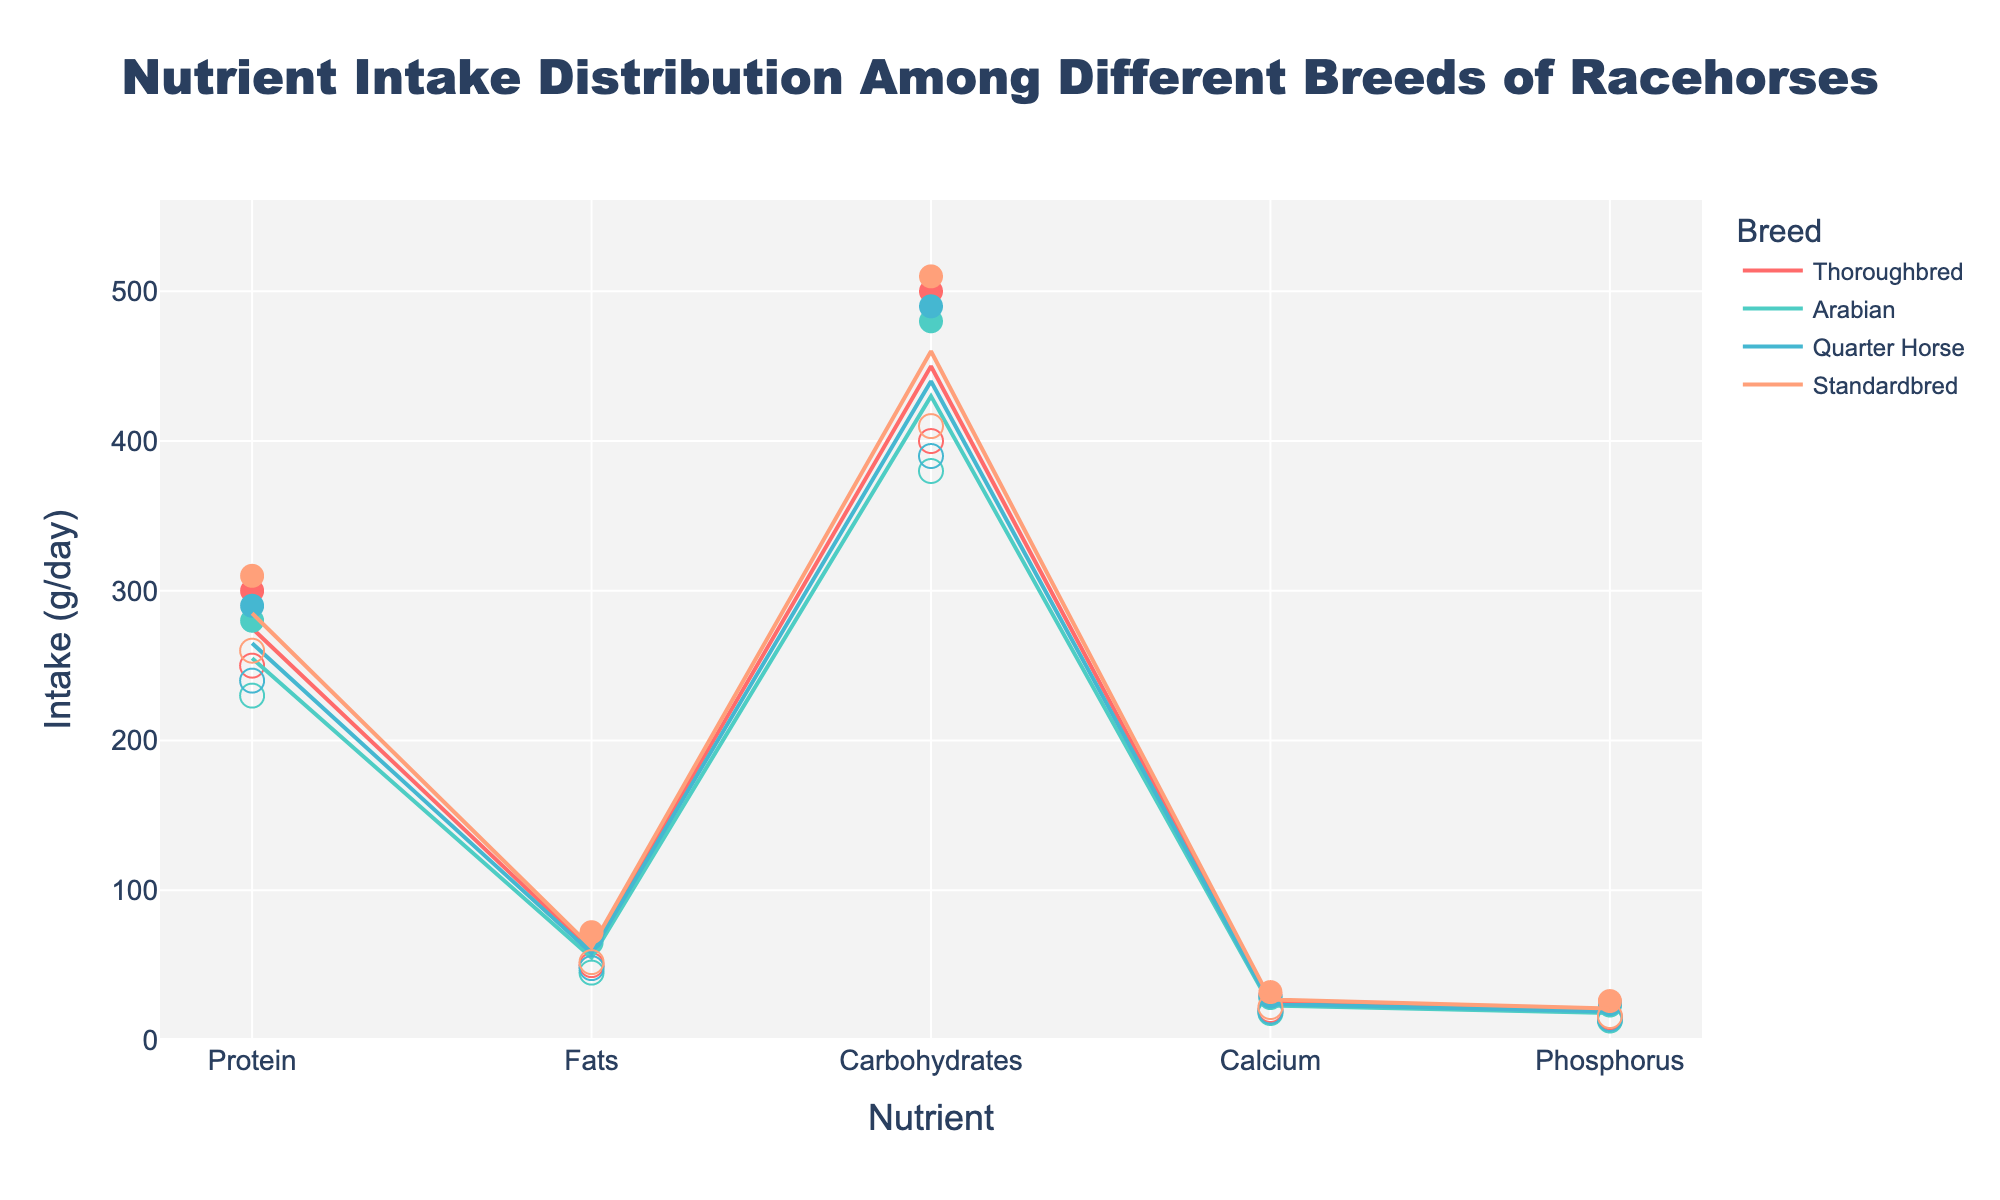Which breed has the highest maximum intake of protein? The highest maximum intake of protein is represented by the dot for protein on the y-axis. Thoroughbreds' max intake of protein is 300g/day, which is the highest.
Answer: Thoroughbred Which nutrient has the smallest range of intake for Thoroughbreds? For each nutrient, find the range (difference between maximum and minimum intake). The smallest difference for Thoroughbreds is in Phosphorus, with a difference of 10g/day.
Answer: Phosphorus Comparing carbohydrates intake, which breed has the lowest minimum intake? Identify the lowest point on the y-axis for carbohydrates among the breeds. Arabian has the lowest minimum intake of carbohydrates at 380g/day.
Answer: Arabian How does the maximum intake of Calcium compare between Thoroughbreds and Standardbreds? Compare the maximum intake values for Calcium between Thoroughbreds (30g/day) and Standardbreds (32g/day). Standardbreds have a slightly higher maximum intake.
Answer: Standardbred has higher What's the average protein intake range for Arabians? Calculate the average by adding the minimum and maximum intake values for protein and dividing by 2 (230g/day + 280g/day) / 2 = 255g/day.
Answer: 255g/day Which breed has the smallest range of intake for fats? Determine the difference between the maximum and minimum intake values for fats for each breed. Thoroughbreds have the smallest range (70g/day - 50g/day = 20g/day).
Answer: Thoroughbred For Quarter Horses, what is the range of intake for carbohydrates? Calculate the difference between the maximum and minimum intakes for carbohydrates: 490g/day - 390g/day = 100g/day.
Answer: 100g/day Which nutrient intake shows the most variability across all breeds? Assess the variability by comparing the ranges of each nutrient across all breeds. Carbohydrates, with ranges around 100g/day, show the most variability.
Answer: Carbohydrates 